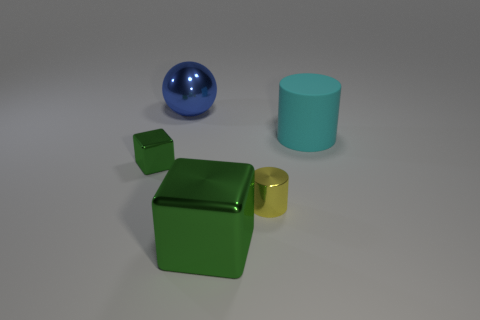Is there any other thing that has the same material as the cyan cylinder?
Ensure brevity in your answer.  No. There is a tiny green metallic thing; what shape is it?
Your answer should be very brief. Cube. What size is the metal object that is the same color as the large shiny block?
Keep it short and to the point. Small. Are the cylinder that is in front of the cyan matte cylinder and the big green object made of the same material?
Make the answer very short. Yes. Is there a big shiny block of the same color as the large ball?
Ensure brevity in your answer.  No. Do the tiny thing that is left of the yellow metallic object and the large shiny object in front of the cyan cylinder have the same shape?
Give a very brief answer. Yes. Are there any cyan objects made of the same material as the large block?
Provide a short and direct response. No. How many cyan objects are big things or tiny metallic cylinders?
Make the answer very short. 1. How big is the thing that is in front of the big rubber cylinder and behind the tiny yellow metal cylinder?
Offer a very short reply. Small. Are there more large cyan cylinders that are on the right side of the cyan rubber cylinder than yellow cylinders?
Make the answer very short. No. 